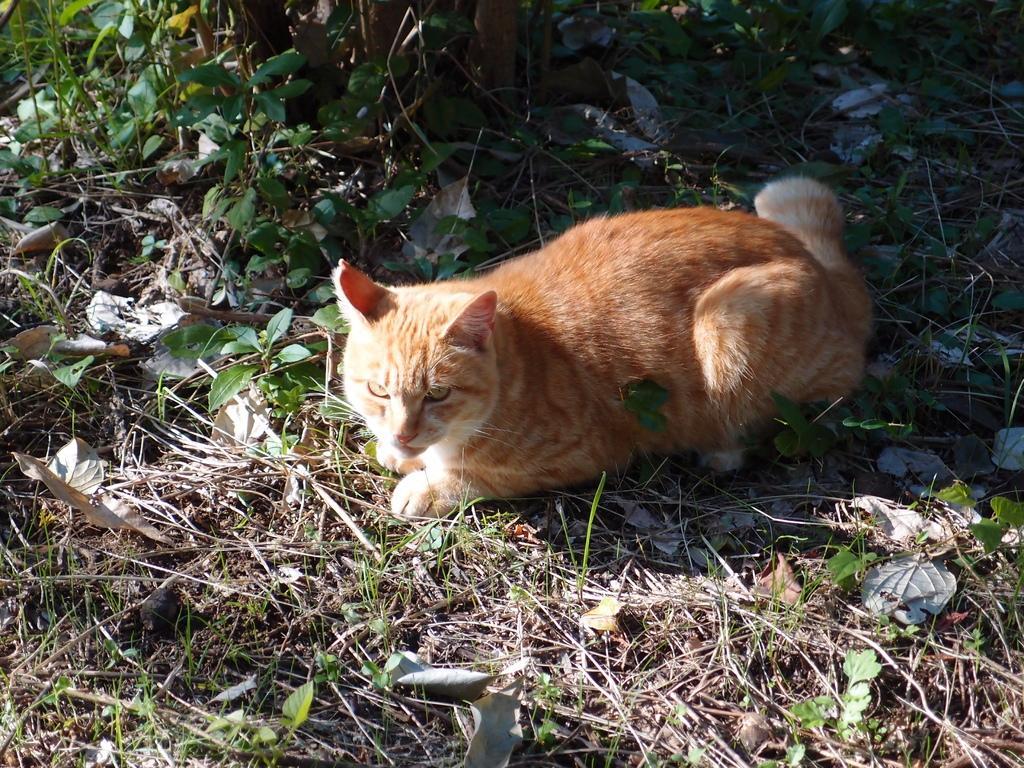How would you summarize this image in a sentence or two? In the center of the image, we can see a cat, lying on the ground and in the background, there are plants and leaves. 